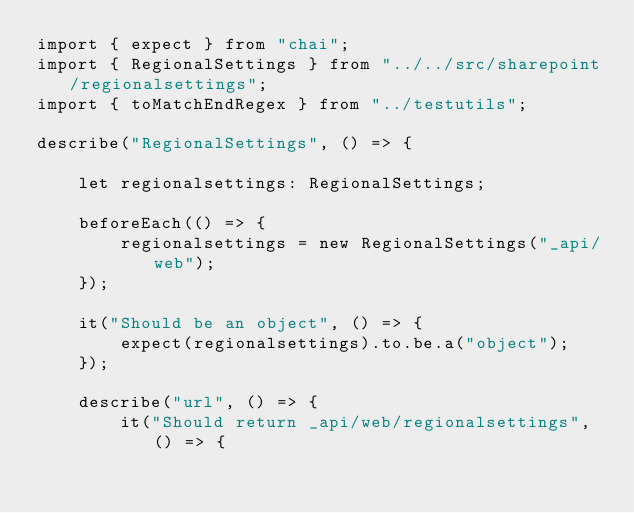<code> <loc_0><loc_0><loc_500><loc_500><_TypeScript_>import { expect } from "chai";
import { RegionalSettings } from "../../src/sharepoint/regionalsettings";
import { toMatchEndRegex } from "../testutils";

describe("RegionalSettings", () => {

    let regionalsettings: RegionalSettings;

    beforeEach(() => {
        regionalsettings = new RegionalSettings("_api/web");
    });

    it("Should be an object", () => {
        expect(regionalsettings).to.be.a("object");
    });

    describe("url", () => {
        it("Should return _api/web/regionalsettings", () => {</code> 